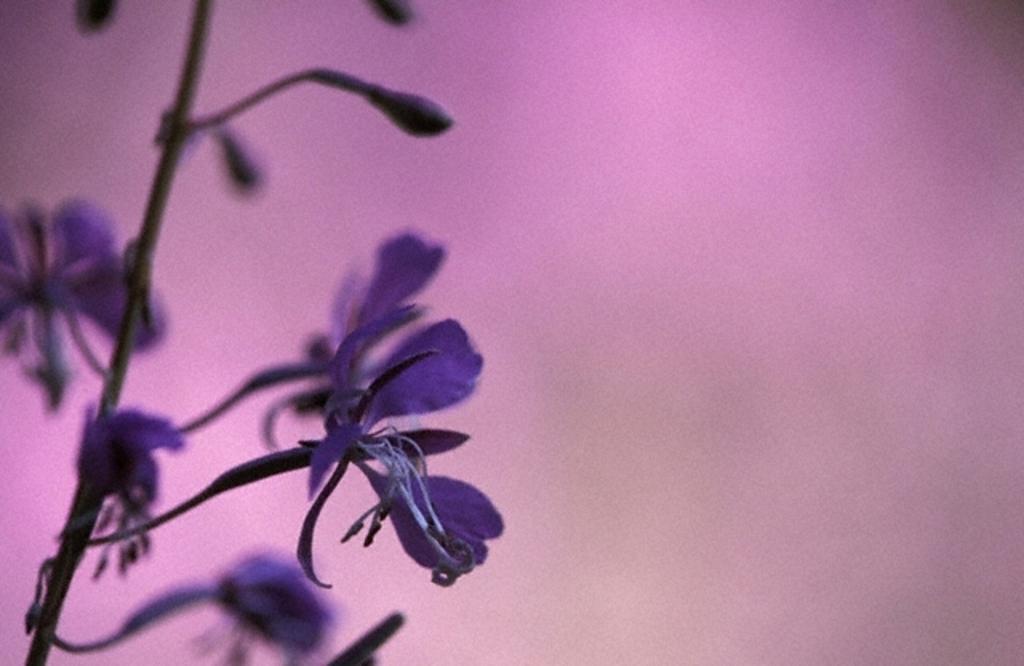Describe this image in one or two sentences. In the picture we can see a flower which is in violet color and the background is pink color. 